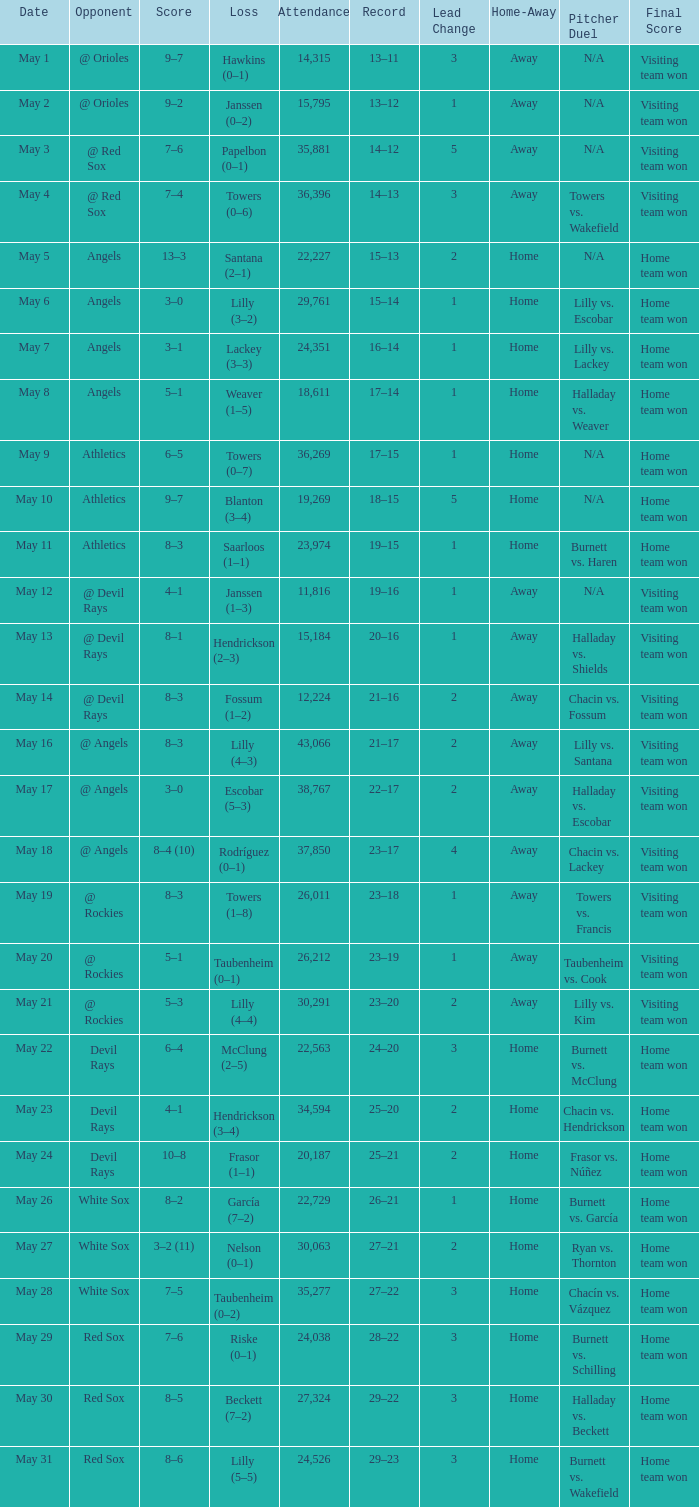What was the average attendance for games with a loss of papelbon (0–1)? 35881.0. 